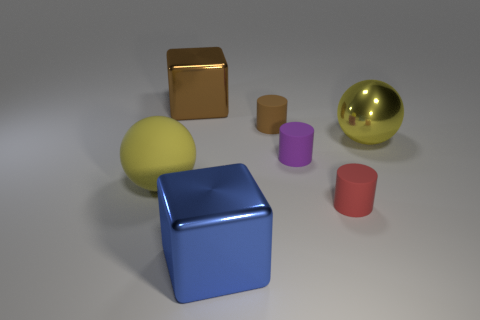Add 2 gray metallic blocks. How many objects exist? 9 Subtract all blocks. How many objects are left? 5 Add 7 tiny balls. How many tiny balls exist? 7 Subtract 1 brown cylinders. How many objects are left? 6 Subtract all red matte cylinders. Subtract all tiny brown objects. How many objects are left? 5 Add 7 big shiny cubes. How many big shiny cubes are left? 9 